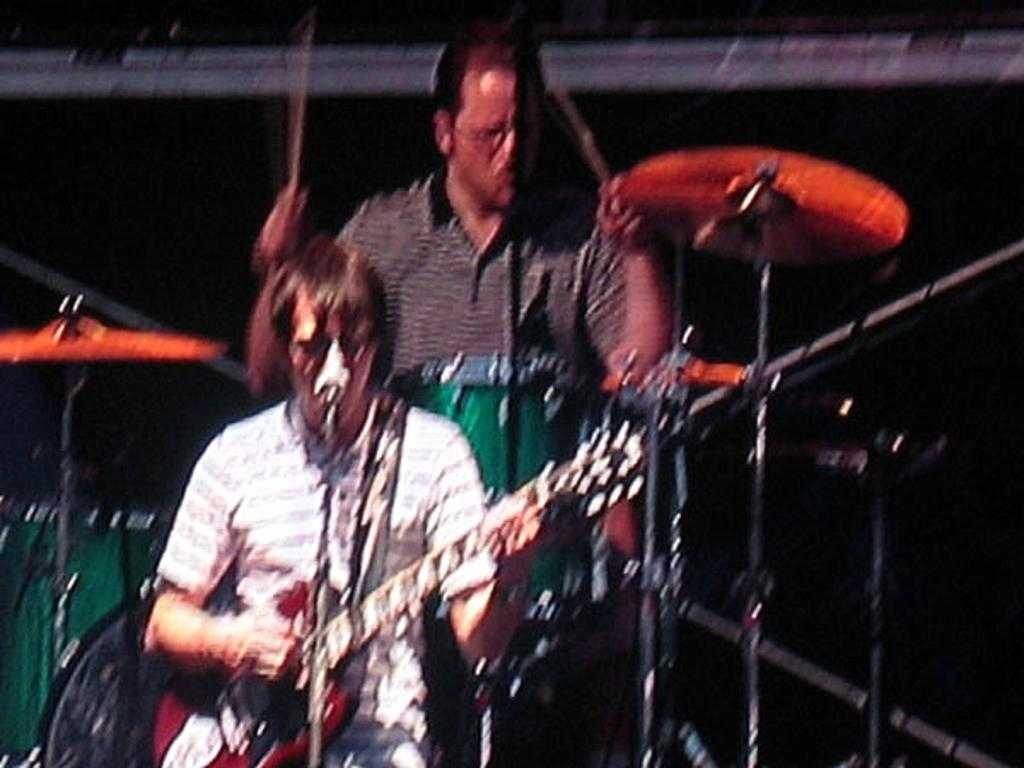How many people are in the image? There are two people in the image. What are the people doing in the image? The people are playing musical instruments. Can you describe any equipment related to sound in the image? Yes, there are microphones in the image. What type of cloth is draped over the sink in the image? There is no sink or cloth present in the image. Can you tell me what request the people are making through their musical instruments? The image does not provide any information about a specific request being made through the musical instruments. 